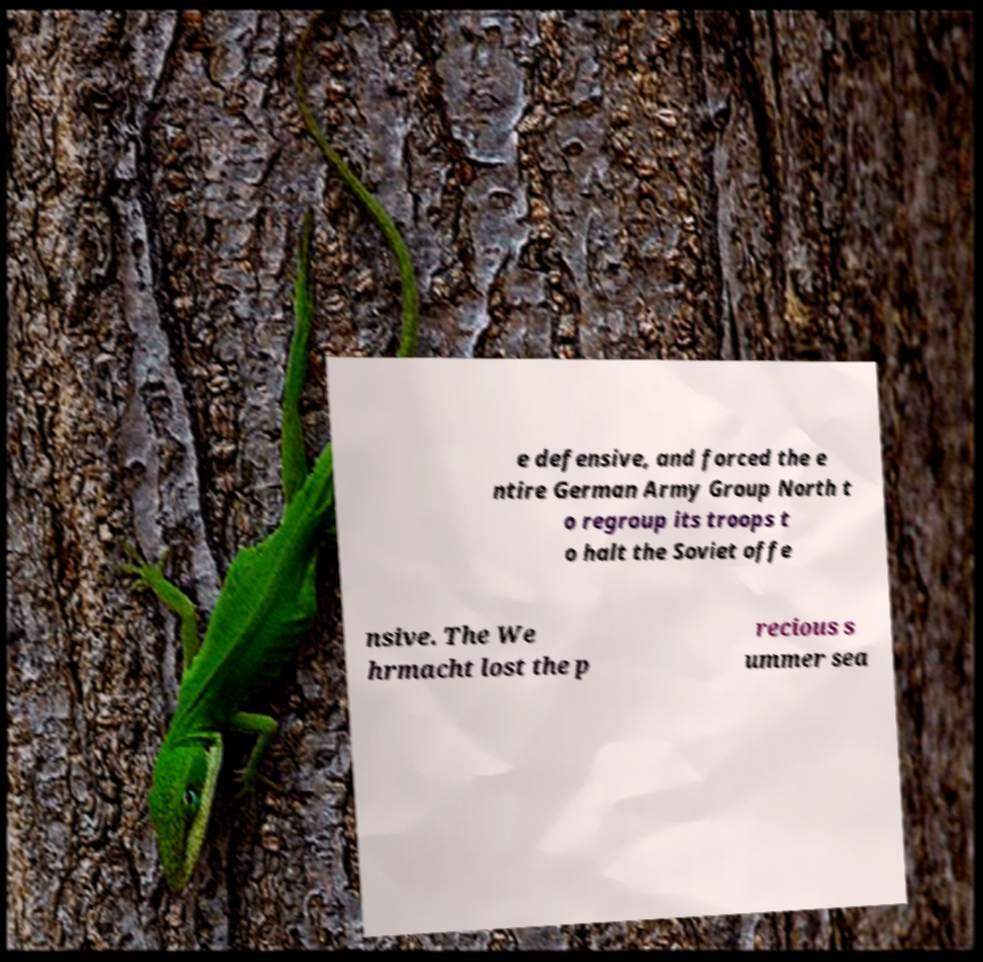Can you accurately transcribe the text from the provided image for me? e defensive, and forced the e ntire German Army Group North t o regroup its troops t o halt the Soviet offe nsive. The We hrmacht lost the p recious s ummer sea 